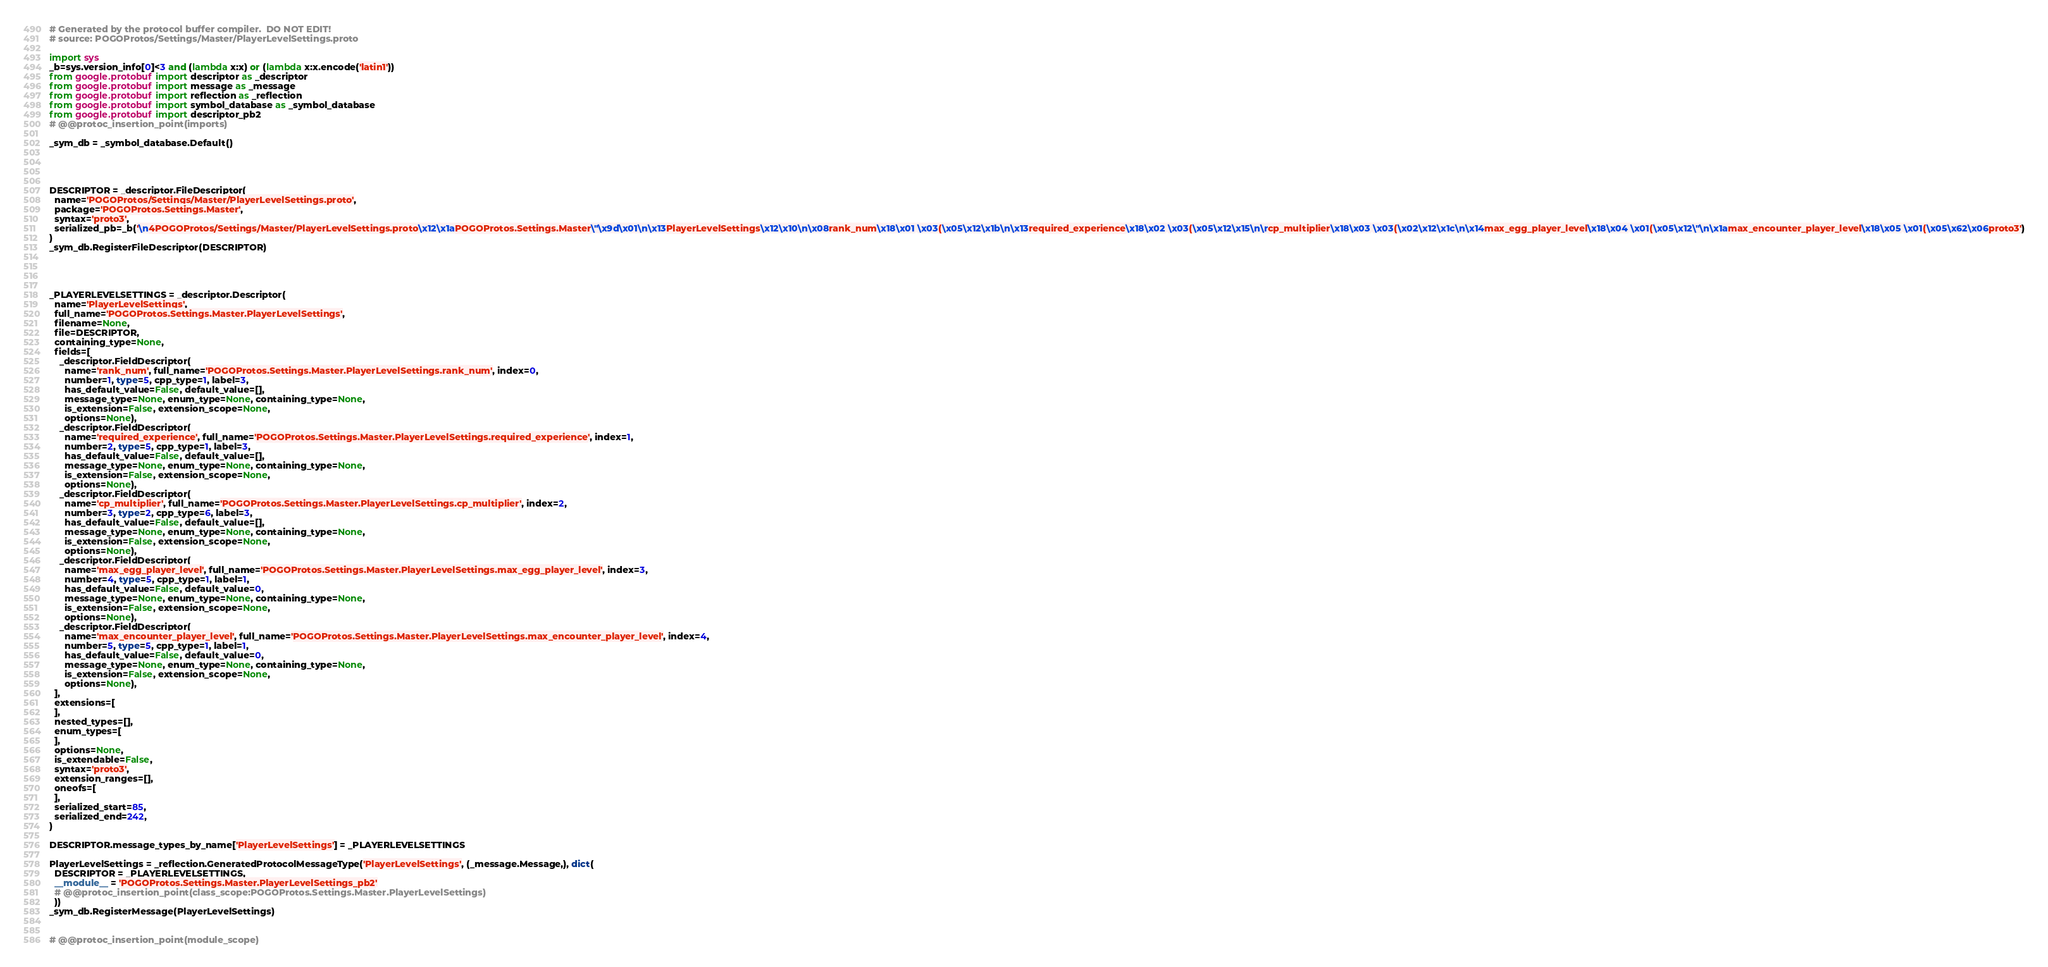Convert code to text. <code><loc_0><loc_0><loc_500><loc_500><_Python_># Generated by the protocol buffer compiler.  DO NOT EDIT!
# source: POGOProtos/Settings/Master/PlayerLevelSettings.proto

import sys
_b=sys.version_info[0]<3 and (lambda x:x) or (lambda x:x.encode('latin1'))
from google.protobuf import descriptor as _descriptor
from google.protobuf import message as _message
from google.protobuf import reflection as _reflection
from google.protobuf import symbol_database as _symbol_database
from google.protobuf import descriptor_pb2
# @@protoc_insertion_point(imports)

_sym_db = _symbol_database.Default()




DESCRIPTOR = _descriptor.FileDescriptor(
  name='POGOProtos/Settings/Master/PlayerLevelSettings.proto',
  package='POGOProtos.Settings.Master',
  syntax='proto3',
  serialized_pb=_b('\n4POGOProtos/Settings/Master/PlayerLevelSettings.proto\x12\x1aPOGOProtos.Settings.Master\"\x9d\x01\n\x13PlayerLevelSettings\x12\x10\n\x08rank_num\x18\x01 \x03(\x05\x12\x1b\n\x13required_experience\x18\x02 \x03(\x05\x12\x15\n\rcp_multiplier\x18\x03 \x03(\x02\x12\x1c\n\x14max_egg_player_level\x18\x04 \x01(\x05\x12\"\n\x1amax_encounter_player_level\x18\x05 \x01(\x05\x62\x06proto3')
)
_sym_db.RegisterFileDescriptor(DESCRIPTOR)




_PLAYERLEVELSETTINGS = _descriptor.Descriptor(
  name='PlayerLevelSettings',
  full_name='POGOProtos.Settings.Master.PlayerLevelSettings',
  filename=None,
  file=DESCRIPTOR,
  containing_type=None,
  fields=[
    _descriptor.FieldDescriptor(
      name='rank_num', full_name='POGOProtos.Settings.Master.PlayerLevelSettings.rank_num', index=0,
      number=1, type=5, cpp_type=1, label=3,
      has_default_value=False, default_value=[],
      message_type=None, enum_type=None, containing_type=None,
      is_extension=False, extension_scope=None,
      options=None),
    _descriptor.FieldDescriptor(
      name='required_experience', full_name='POGOProtos.Settings.Master.PlayerLevelSettings.required_experience', index=1,
      number=2, type=5, cpp_type=1, label=3,
      has_default_value=False, default_value=[],
      message_type=None, enum_type=None, containing_type=None,
      is_extension=False, extension_scope=None,
      options=None),
    _descriptor.FieldDescriptor(
      name='cp_multiplier', full_name='POGOProtos.Settings.Master.PlayerLevelSettings.cp_multiplier', index=2,
      number=3, type=2, cpp_type=6, label=3,
      has_default_value=False, default_value=[],
      message_type=None, enum_type=None, containing_type=None,
      is_extension=False, extension_scope=None,
      options=None),
    _descriptor.FieldDescriptor(
      name='max_egg_player_level', full_name='POGOProtos.Settings.Master.PlayerLevelSettings.max_egg_player_level', index=3,
      number=4, type=5, cpp_type=1, label=1,
      has_default_value=False, default_value=0,
      message_type=None, enum_type=None, containing_type=None,
      is_extension=False, extension_scope=None,
      options=None),
    _descriptor.FieldDescriptor(
      name='max_encounter_player_level', full_name='POGOProtos.Settings.Master.PlayerLevelSettings.max_encounter_player_level', index=4,
      number=5, type=5, cpp_type=1, label=1,
      has_default_value=False, default_value=0,
      message_type=None, enum_type=None, containing_type=None,
      is_extension=False, extension_scope=None,
      options=None),
  ],
  extensions=[
  ],
  nested_types=[],
  enum_types=[
  ],
  options=None,
  is_extendable=False,
  syntax='proto3',
  extension_ranges=[],
  oneofs=[
  ],
  serialized_start=85,
  serialized_end=242,
)

DESCRIPTOR.message_types_by_name['PlayerLevelSettings'] = _PLAYERLEVELSETTINGS

PlayerLevelSettings = _reflection.GeneratedProtocolMessageType('PlayerLevelSettings', (_message.Message,), dict(
  DESCRIPTOR = _PLAYERLEVELSETTINGS,
  __module__ = 'POGOProtos.Settings.Master.PlayerLevelSettings_pb2'
  # @@protoc_insertion_point(class_scope:POGOProtos.Settings.Master.PlayerLevelSettings)
  ))
_sym_db.RegisterMessage(PlayerLevelSettings)


# @@protoc_insertion_point(module_scope)
</code> 